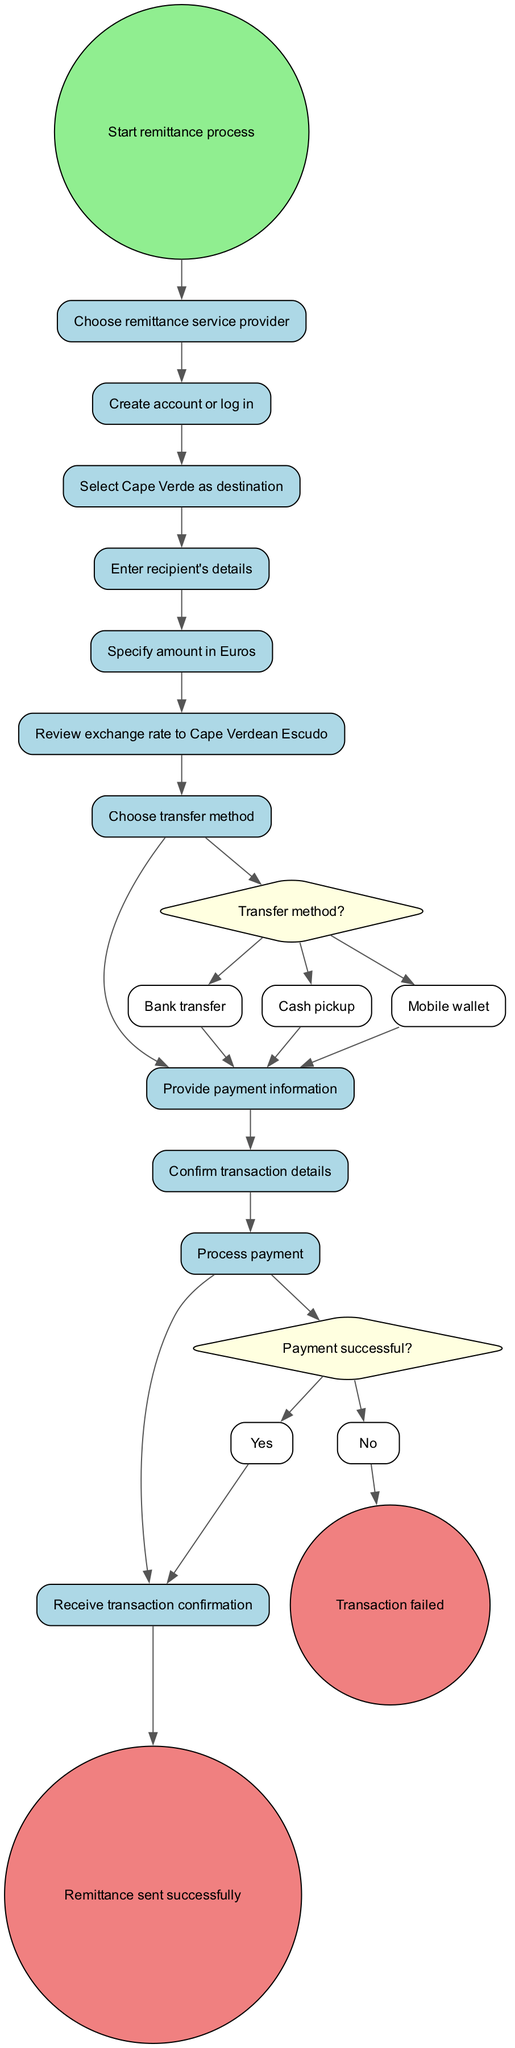What is the initial node of the diagram? The initial node indicated in the diagram is "Start remittance process," which represents the beginning of the remittance workflow.
Answer: Start remittance process How many activities are there in the diagram? There are a total of 10 activities listed in the diagram, each representing a step in the remittance process.
Answer: 10 What decision point follows the activity of "Specify amount in Euros"? The decision point that follows is "Transfer method?", which asks the user to choose the appropriate transfer method after specifying the amount.
Answer: Transfer method? What factors can result in a transaction failing? The diagram specifies that if the "Payment successful?" decision responds with "No," it leads to the "Transaction failed" end node, indicating that unsuccessful payments lead to transaction failures.
Answer: Payment unsuccessful What are the possible transfer methods available in the decision point? The options available for the transfer method decision are "Bank transfer," "Cash pickup," and "Mobile wallet," indicating the multiple ways to send money.
Answer: Bank transfer, Cash pickup, Mobile wallet Which activity comes immediately before the transaction is confirmed? The activity that comes immediately before the "Confirm transaction details" step is "Provide payment information," as it is a necessary prerequisite for confirming transaction details.
Answer: Provide payment information What is the end node if the payment is successful? If the payment is successful, the end node reached is "Remittance sent successfully," indicating that the process ends positively when the payment completes successfully.
Answer: Remittance sent successfully What is the purpose of the "Review exchange rate to Cape Verdean Escudo" activity? The purpose of this activity is to ensure that the sender understands the conversion rate of Euros to Cape Verdean Escudo before proceeding with the transaction.
Answer: To review the exchange rate What is the sequence of activities from starting the process to confirming the details? The sequence of activities is: "Start remittance process" → "Choose remittance service provider" → "Create account or log in" → "Select Cape Verde as destination" → "Enter recipient's details" → "Specify amount in Euros" → "Review exchange rate to Cape Verdean Escudo" → "Choose transfer method" → "Provide payment information" → "Confirm transaction details."
Answer: Sequential activities listed 